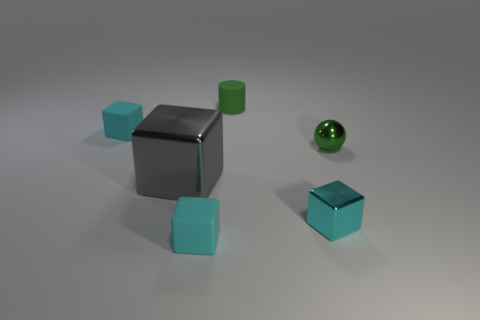Are there any other things that are the same size as the gray cube?
Give a very brief answer. No. How many objects are metallic cubes that are to the left of the green matte object or tiny cyan matte things on the left side of the gray thing?
Make the answer very short. 2. What number of other things are the same color as the cylinder?
Your response must be concise. 1. There is a small object that is in front of the cyan metal cube; is its shape the same as the large shiny thing?
Your response must be concise. Yes. Are there fewer tiny cyan things left of the small metal block than big things?
Make the answer very short. No. Is there a small brown ball made of the same material as the large cube?
Your answer should be very brief. No. What is the material of the green thing that is the same size as the ball?
Ensure brevity in your answer.  Rubber. Are there fewer rubber objects in front of the cyan metal block than large gray metallic objects on the right side of the large gray thing?
Make the answer very short. No. There is a metallic thing that is both behind the cyan metal block and on the right side of the green matte thing; what shape is it?
Provide a short and direct response. Sphere. How many big gray metallic objects have the same shape as the green rubber thing?
Offer a terse response. 0. 